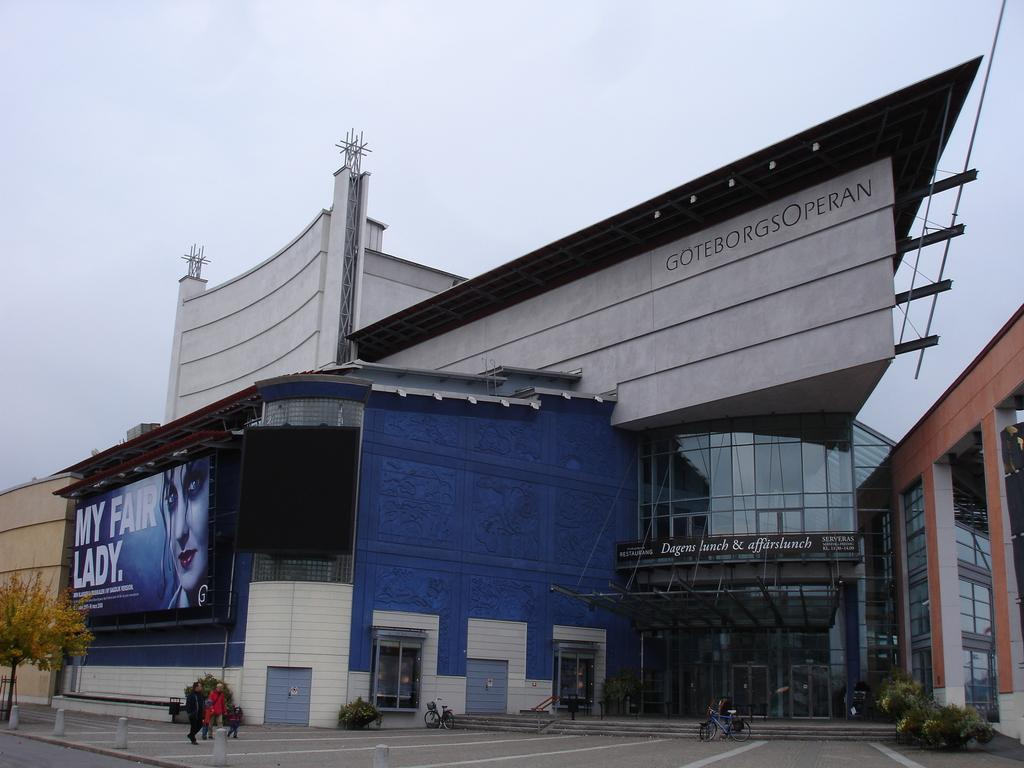What type of vehicles can be seen in the image? There are bicycles in the image. What natural elements are present in the image? There are trees in the image. What are the people in the image doing? There are people walking on a footpath in the image. What type of structures can be seen in the image? There are buildings in the image. What additional object is present in the image? There is a poster in the image. What architectural feature is visible in the image? There are steps in the image. What can be seen in the background of the image? The sky is visible in the background of the image. What type of laborer is working on the poster in the image? There is no laborer working on the poster in the image. What type of achiever is depicted on the poster in the image? There is no achiever depicted on the poster in the image. 